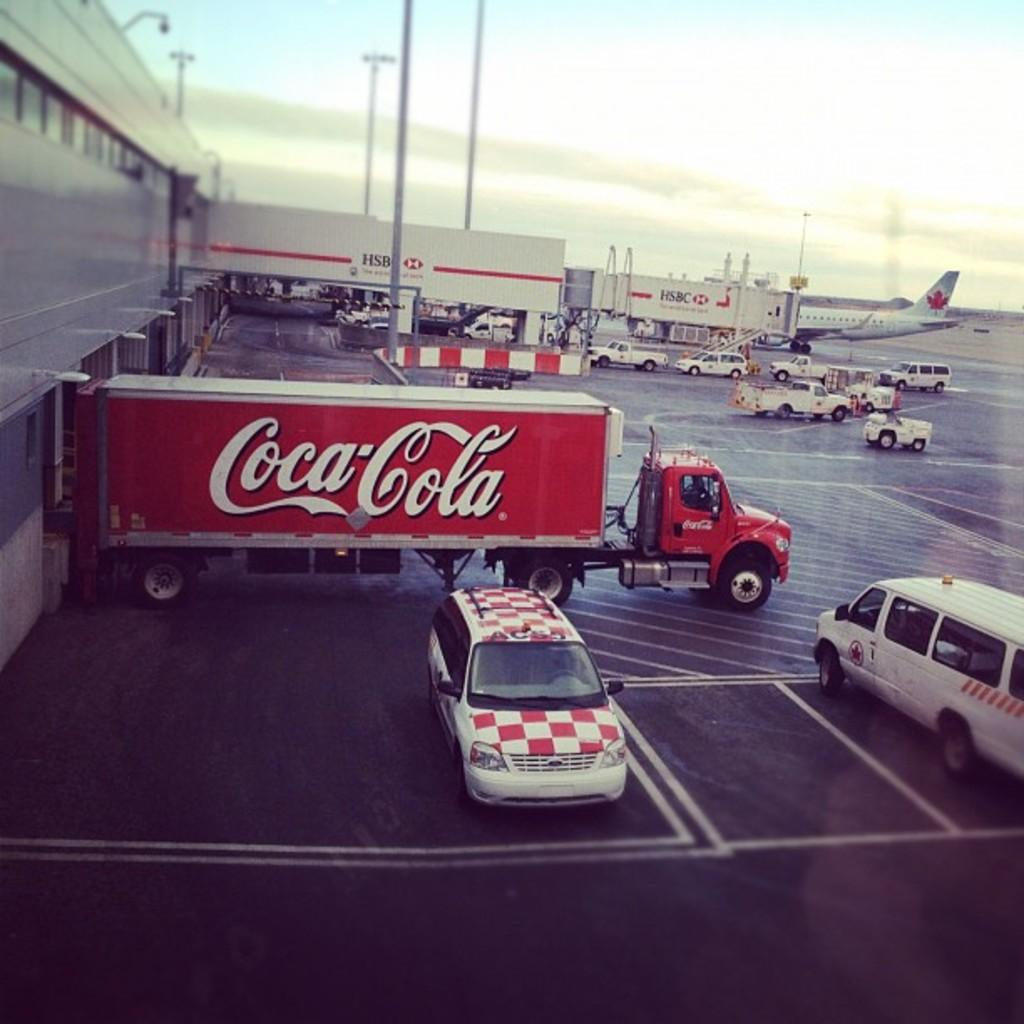<image>
Summarize the visual content of the image. A coca cola truck sitting in a parking lot waitng to be loaded up 